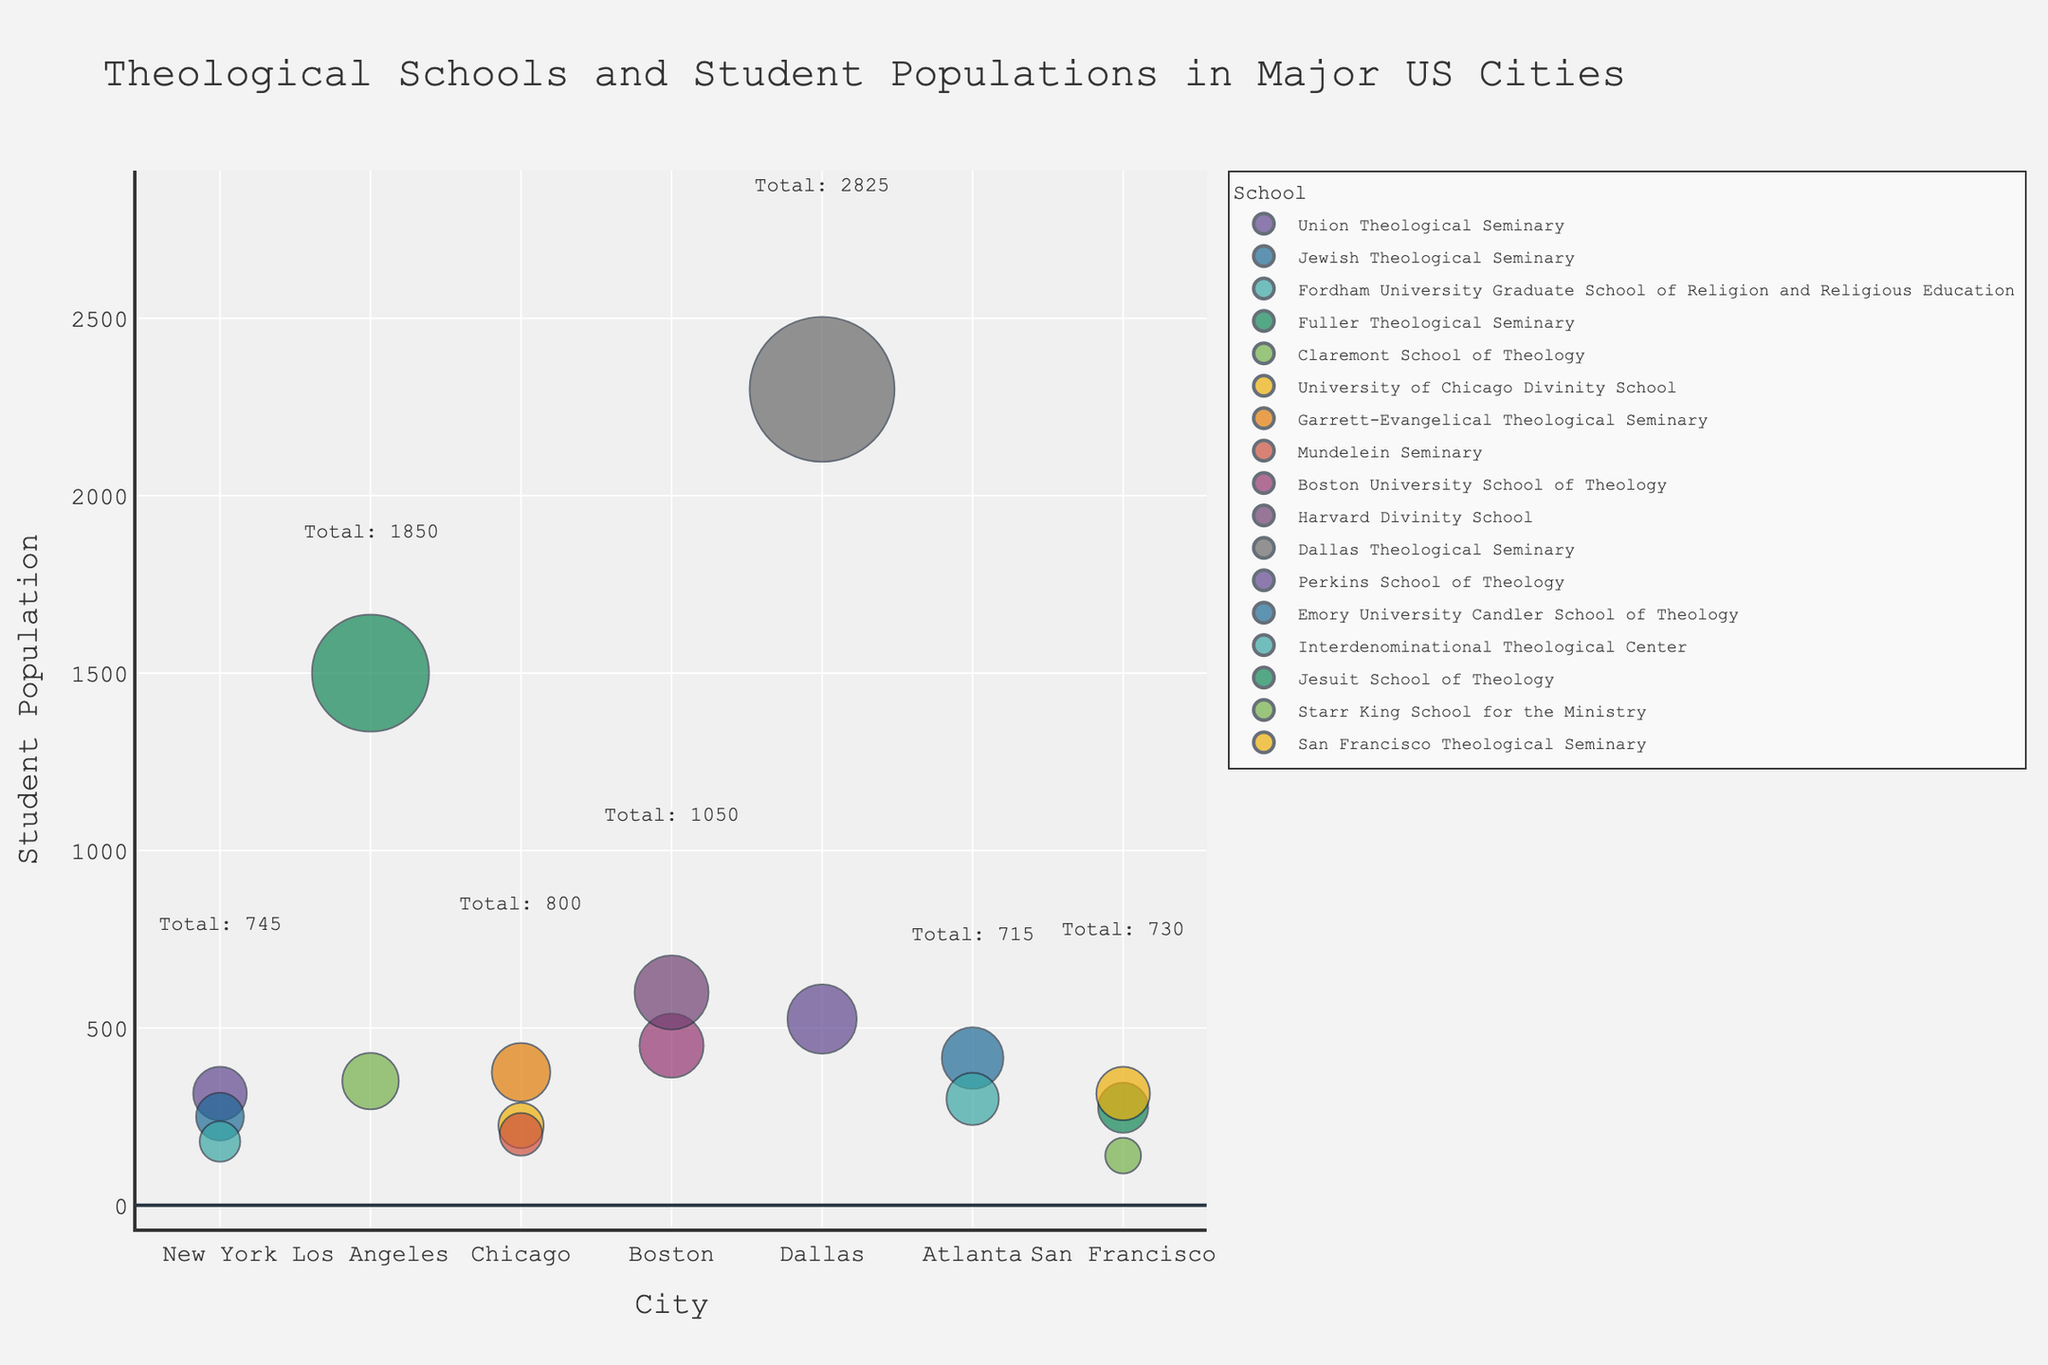What is the title of the figure? The title of the figure is displayed prominently at the top and is designed to provide a clear overview of what the figure represents.
Answer: "Theological Schools and Student Populations in Major US Cities" How many schools are located in New York? To find this, we count the number of bubbles in the New York section of the figure. Each bubble in New York represents a different theological school.
Answer: 3 Which city has the highest single student population for a school? To determine this, find the city that has the largest bubble. The size of the bubble corresponds to the student population.
Answer: Dallas What is the total student population in Los Angeles? To answer this, we need to sum up the student populations of all the schools in Los Angeles. The total can be calculated by adding the values shown in the bubbles for Los Angeles.
Answer: 1850 Compare the student populations of the Harvard Divinity School and the Union Theological Seminary. Which is larger? Find and compare the sizes of the bubbles for Harvard Divinity School (located in Boston) and Union Theological Seminary (located in New York) based on their color and size.
Answer: Harvard Divinity School How does the student population of the University of Chicago Divinity School compare to that of Boston University School of Theology? To determine this, we compare the sizes of the corresponding bubbles for these two schools by both color and position: University of Chicago in Chicago versus Boston University in Boston.
Answer: Boston University School of Theology What is the total student population across all theological schools in Atlanta? To find this, we sum up the student populations of Emory University Candler School of Theology and the Interdenominational Theological Center, as their bubbles represent the total number of students.
Answer: 715 Identify the city with the largest number of theological schools. The city with the most distinct bubbles, each representing a different theological school, will have the largest number of schools.
Answer: Chicago Among all the cities, which has the smallest bubble, and which school does it represent? Look for the smallest bubbles in the entire figure and identify the city and school. The size corresponds to the smallest student population.
Answer: San Francisco, Starr King School for the Ministry What is the combined total student population for theological schools in Dallas and Chicago? To find the combined total, add up all the student populations for schools in Dallas and Chicago by summing up their respective bubble sizes.
Answer: 2900 